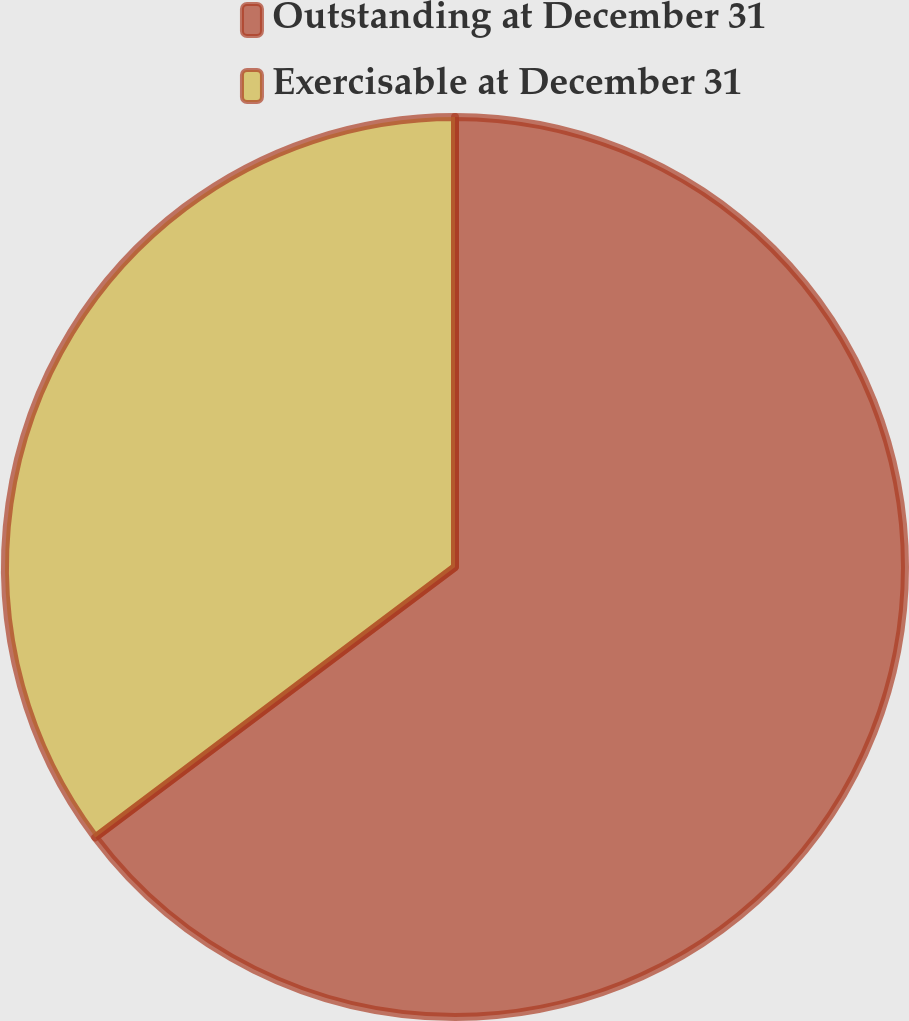Convert chart. <chart><loc_0><loc_0><loc_500><loc_500><pie_chart><fcel>Outstanding at December 31<fcel>Exercisable at December 31<nl><fcel>64.74%<fcel>35.26%<nl></chart> 